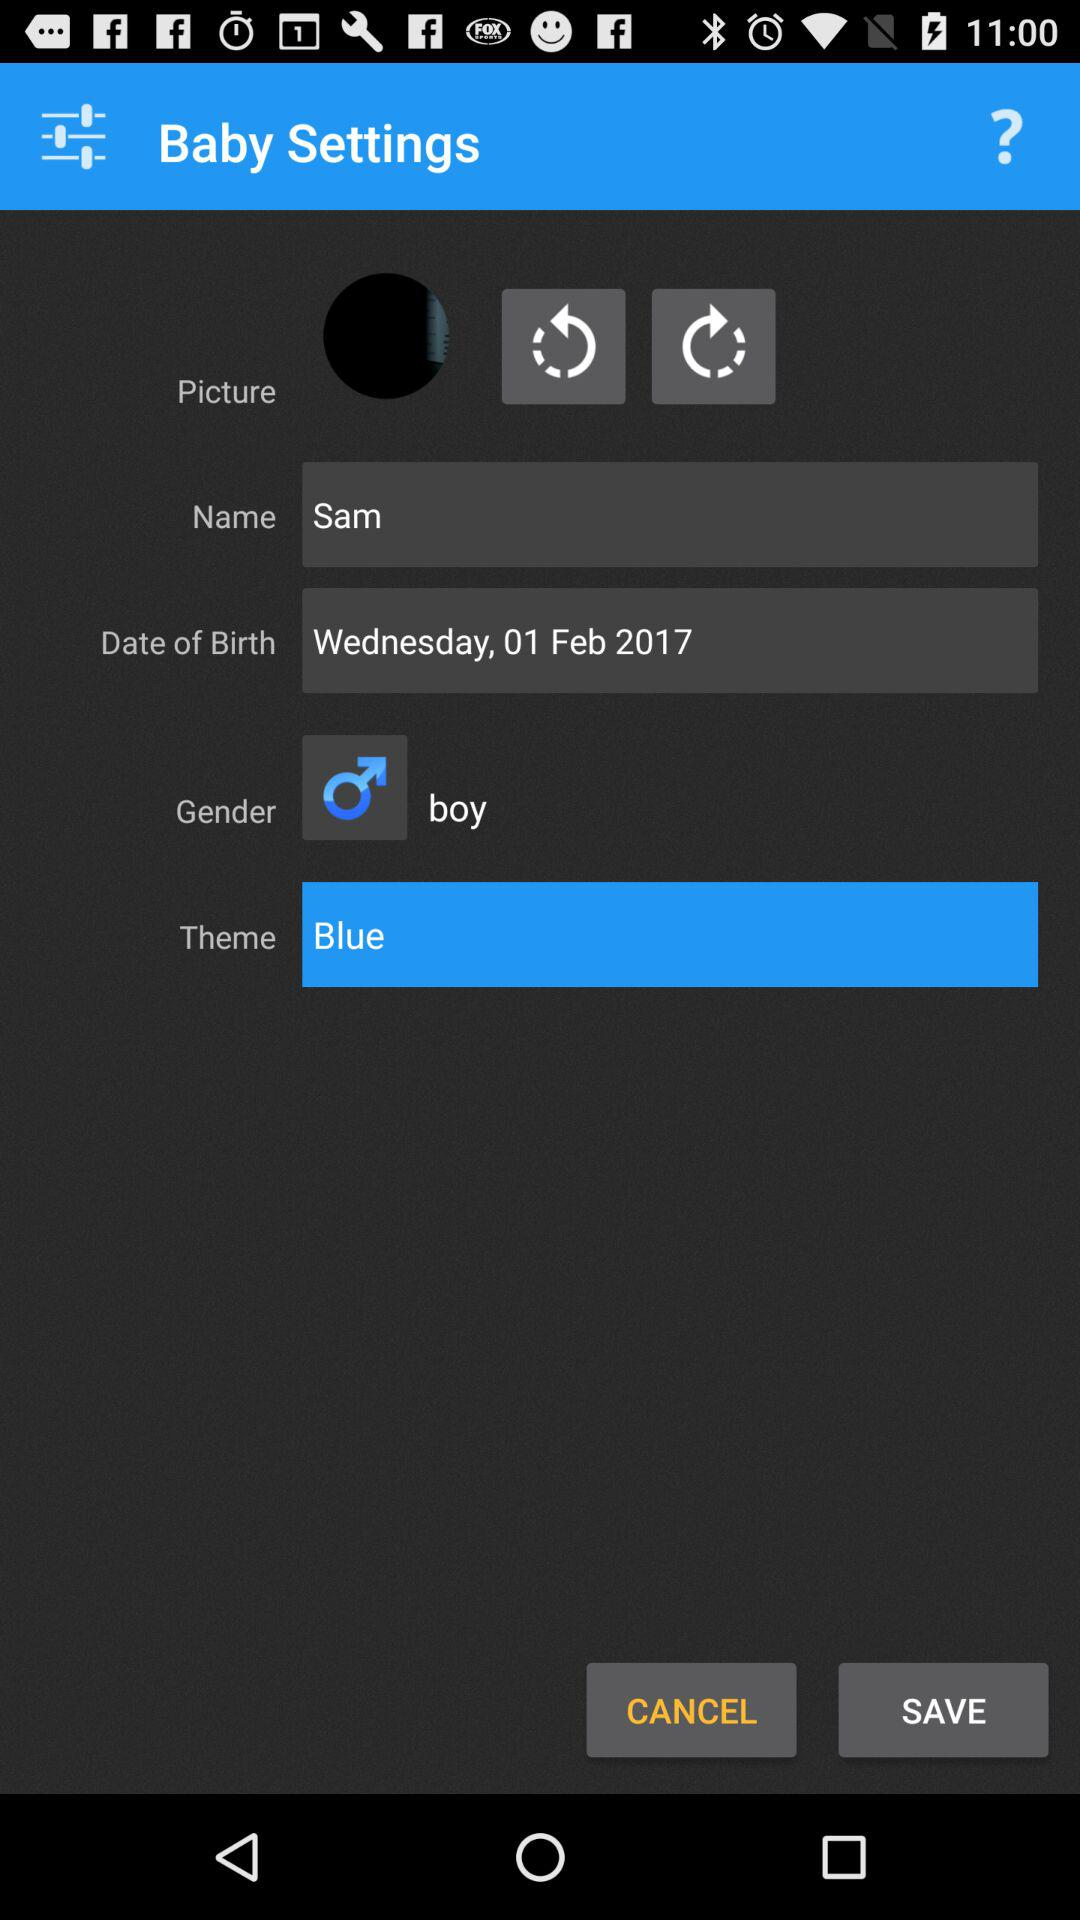What is the user name? The user name is Sam. 